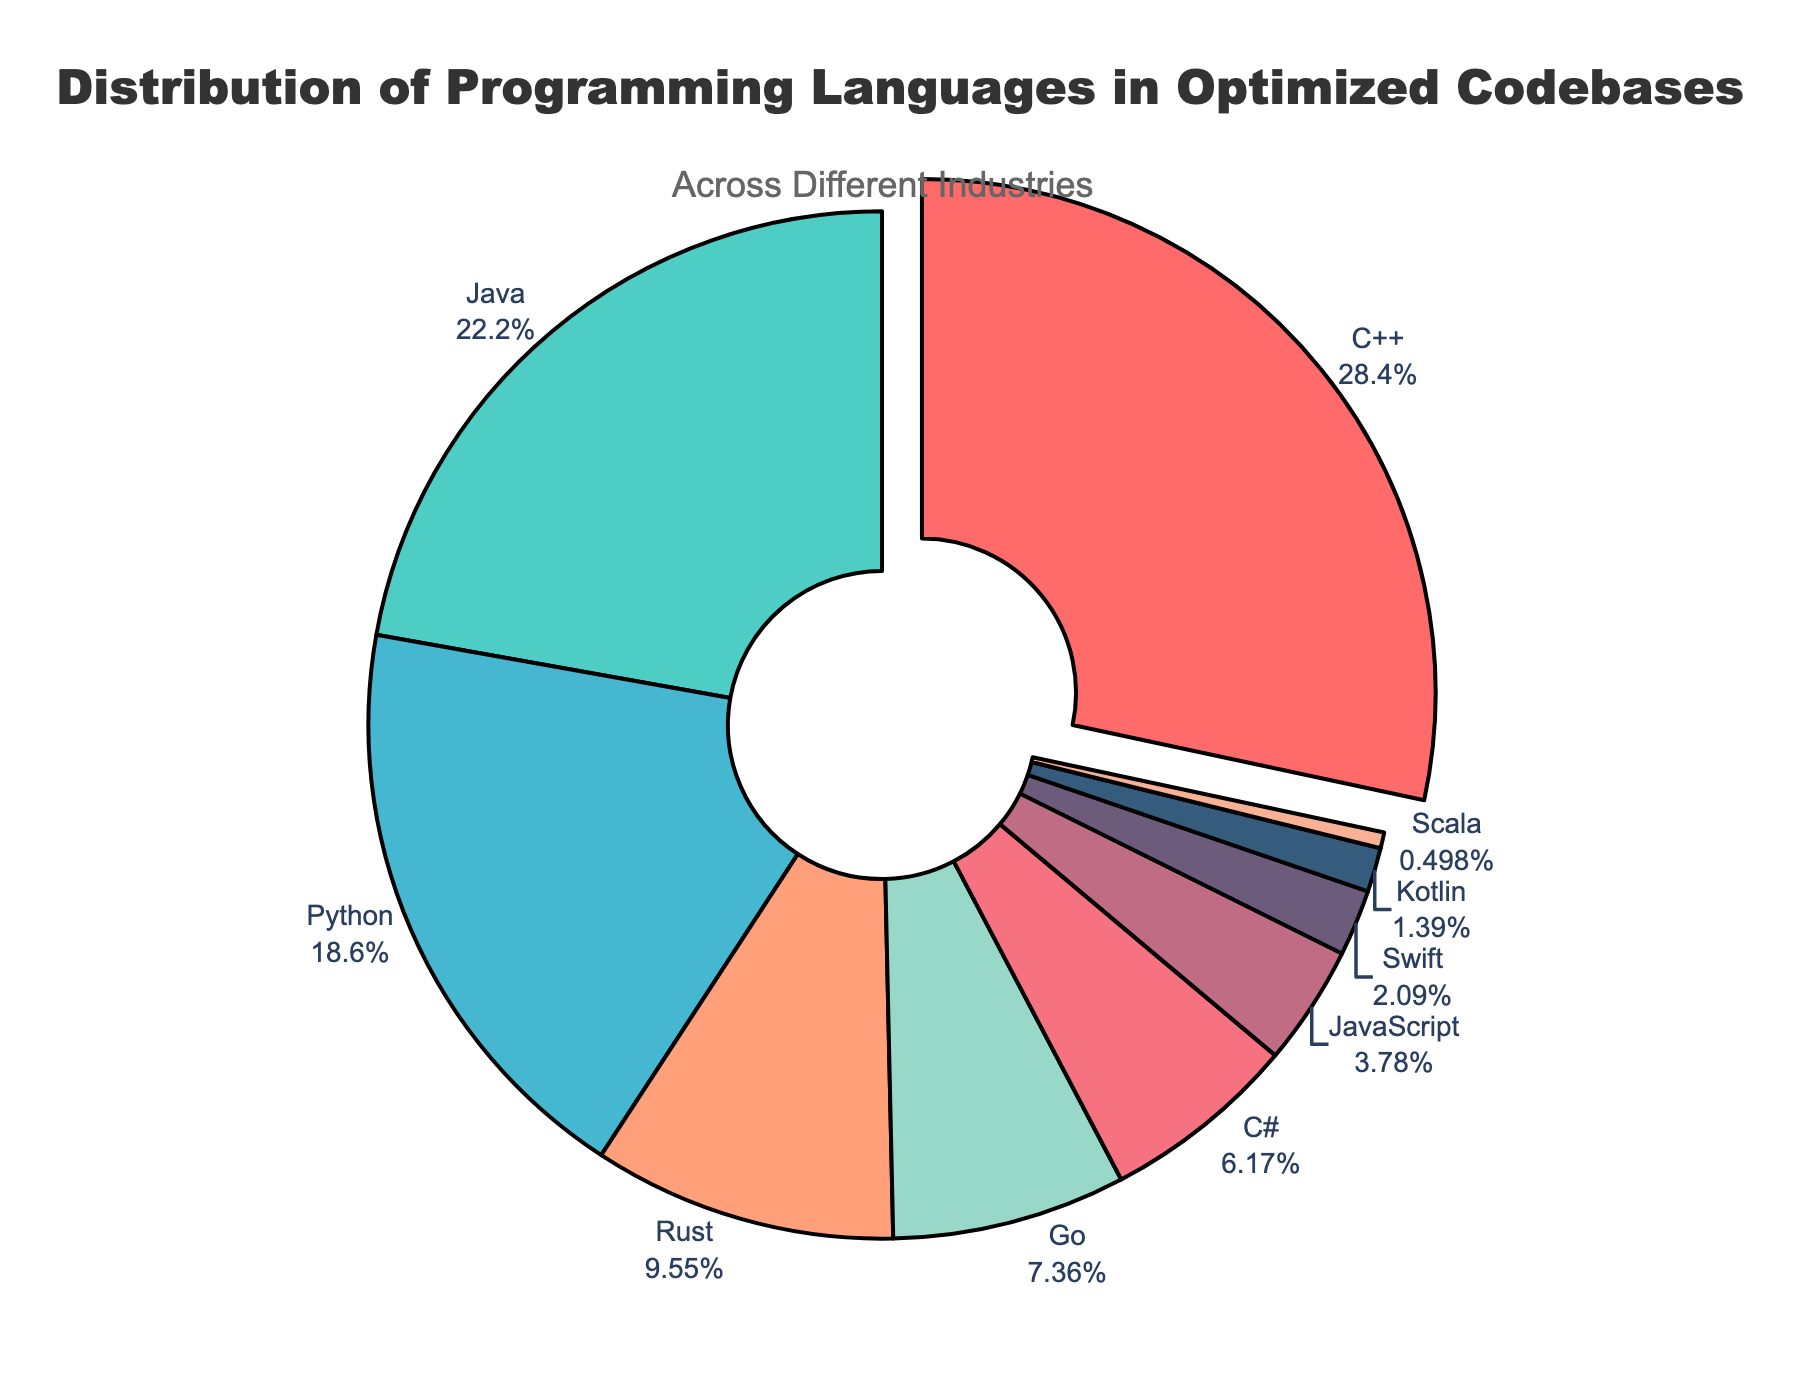What's the most commonly used programming language in optimized codebases across different industries? By observing the pie chart, identify the programming language with the largest segment. Here, C++ has the largest segment as indicated by the visual representation and additional pulling effect.
Answer: C++ What percentage of the programming languages used in optimized codebases is contributed by Java and Python combined? Look at the individual percentages for Java (22.3%) and Python (18.7%) and sum them up. The combined percentage is 22.3% + 18.7%.
Answer: 41% Which programming language is the least used in optimized codebases across different industries? Identify the smallest segment in the pie chart. Here, Scala represents the smallest percentage.
Answer: Scala Are there more codebases using Rust or Go? By how much? Compare the segments of Rust (9.6%) and Go (7.4%). Rust has the higher percentage, so subtract Go's percentage from Rust's. The difference is 9.6% - 7.4%.
Answer: Rust by 2.2% Which color represents the Python programming language in the chart, and what is its percentage? Locate the segment labeled Python and observe its color. The color for Python is visually represented as blue, and its percentage is shown as 18.7%.
Answer: Blue, 18.7% What is the sum of the percentages for Go, C#, and JavaScript? Add the percentages: Go (7.4%), C# (6.2%), and JavaScript (3.8%). The sum is 7.4% + 6.2% + 3.8%.
Answer: 17.4% Does JavaScript or Swift account for more of the optimized codebases, and by how much? Compare the segments for JavaScript (3.8%) and Swift (2.1%). JavaScript has the higher percentage. Subtract Swift's percentage from JavaScript's. The difference is 3.8% - 2.1%.
Answer: JavaScript by 1.7% What is the average percentage of codebases using Kotlin, Scala, and Swift? Average the given percentages for Kotlin (1.4%), Scala (0.5%), and Swift (2.1%). Sum these values and divide by 3. (1.4 + 0.5 + 2.1) / 3.
Answer: 1.33% Which two programming languages combined contribute closest to 50% of the total optimized codebases? Evaluate the pairs of percentages: C++ (28.5%) and Java (22.3%) combined equal 50.8%, which is the combination nearest to 50%.
Answer: C++ and Java What percentage of the programming languages used are not among the top 3 (C++, Java, Python)? First, sum the percentages of the top 3 languages: C++ (28.5%), Java (22.3%), Python (18.7%). This equals 69.5%. Subtract this from 100% to find the percentage not in the top 3. 100% - 69.5%
Answer: 30.5% 